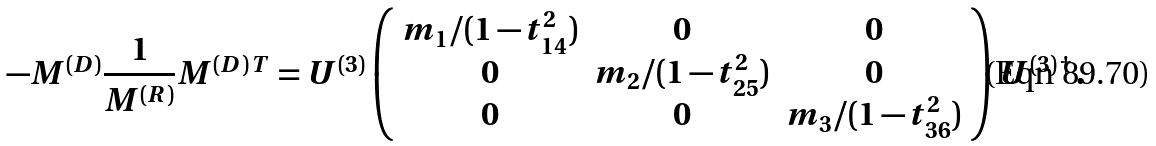Convert formula to latex. <formula><loc_0><loc_0><loc_500><loc_500>- M ^ { ( D ) } \frac { 1 } { M ^ { ( R ) } } M ^ { ( D ) \, T } = U ^ { ( 3 ) } \left ( \begin{array} { c c c } m _ { 1 } / ( 1 - t ^ { 2 } _ { 1 4 } ) & 0 & 0 \\ 0 & m _ { 2 } / ( 1 - t ^ { 2 } _ { 2 5 } ) & 0 \\ 0 & 0 & m _ { 3 } / ( 1 - t ^ { 2 } _ { 3 6 } ) \end{array} \right ) U ^ { ( 3 ) \, \dagger } \, .</formula> 